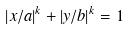Convert formula to latex. <formula><loc_0><loc_0><loc_500><loc_500>| x / a | ^ { k } + | y / b | ^ { k } = 1</formula> 